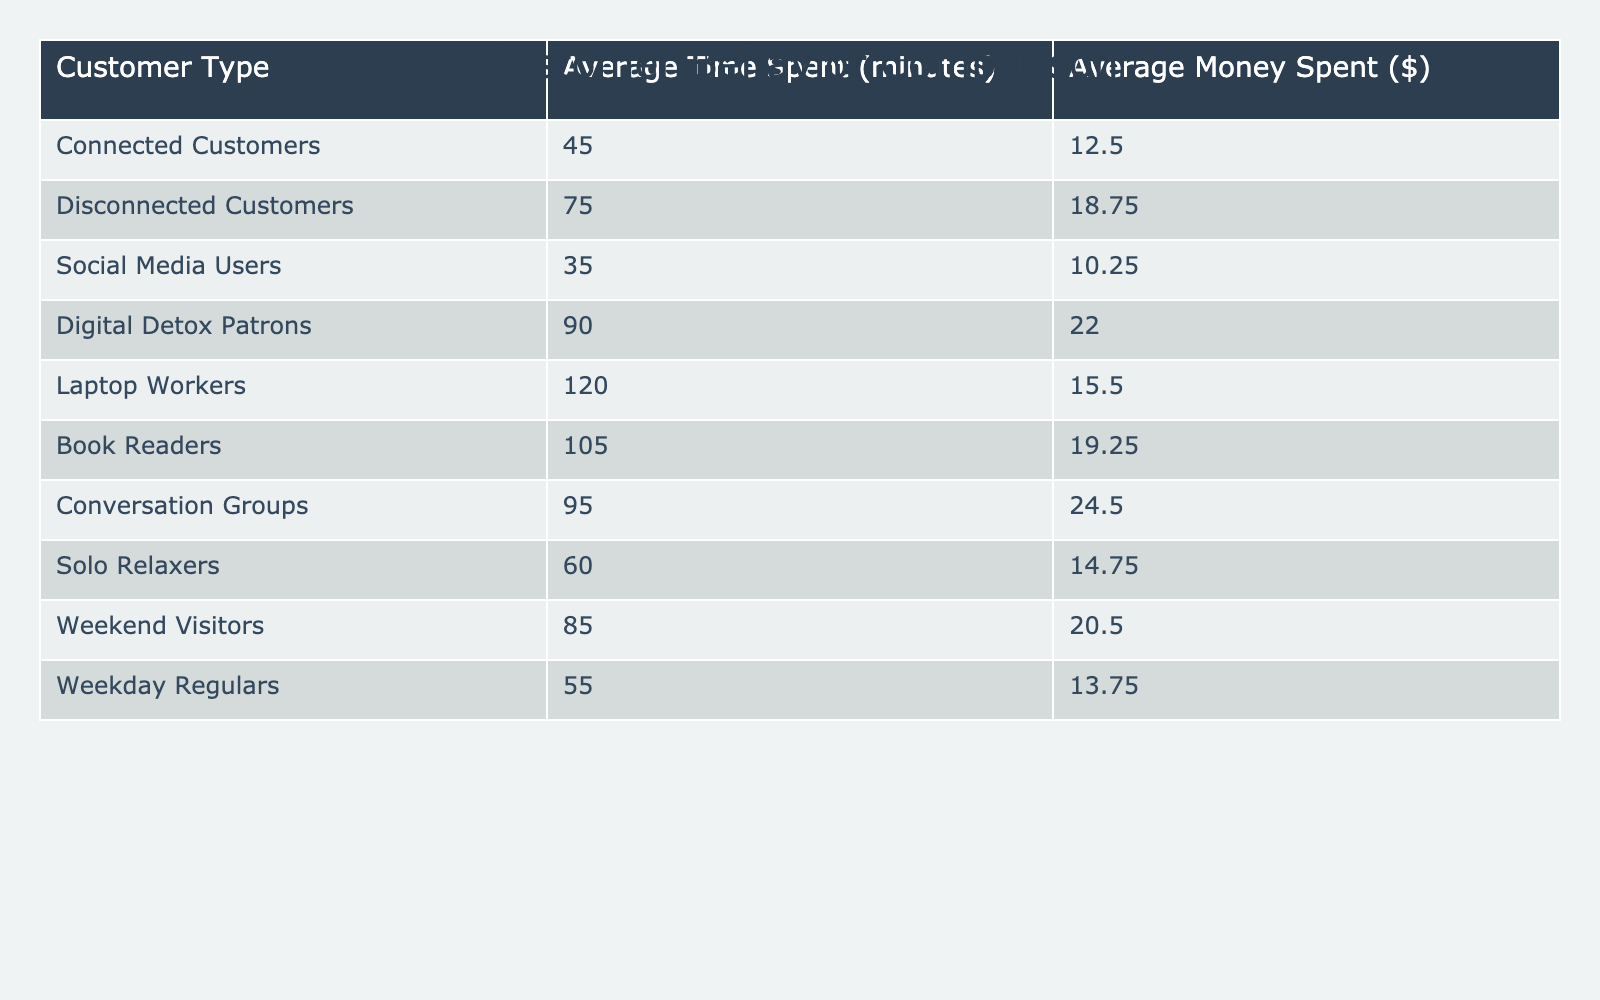What is the average time spent by disconnected customers? According to the table, the average time spent by disconnected customers is explicitly listed as 75 minutes.
Answer: 75 minutes What is the average money spent by connected customers? The table shows the average money spent by connected customers to be $12.50.
Answer: $12.50 Which group spends more on average, connected or disconnected customers? Upon comparing the average money spent by connected customers ($12.50) with disconnected customers ($18.75), disconnected customers spend more.
Answer: Disconnected customers What is the difference in average time spent between connected customers and digital detox patrons? The average time spent by connected customers is 45 minutes, while digital detox patrons spend 90 minutes. The difference is 90 - 45 = 45 minutes.
Answer: 45 minutes How much more money do disconnected customers spend compared to connected customers? Disconnected customers spend an average of $18.75, while connected customers spend $12.50. The difference is $18.75 - $12.50 = $6.25.
Answer: $6.25 What is the total average time spent by connected and disconnected customers combined? The total average time for both categories is 45 minutes (connected) + 75 minutes (disconnected) = 120 minutes.
Answer: 120 minutes True or False: Social media users spend more time on average than weekend visitors. The average time spent by social media users is 35 minutes and weekend visitors spend 85 minutes, so the statement is false.
Answer: False What is the average time spent by all customers in the table? To find the average, sum all average times: 45 + 75 + 35 + 90 + 120 + 105 + 95 + 60 + 85 + 55 = 765 minutes, then divide by the number of groups (10): 765 / 10 = 76.5 minutes.
Answer: 76.5 minutes Which customer type has the highest average money spent, and what is that amount? Looking through the average money spent values, conversation groups have the highest at $24.50.
Answer: Conversation groups, $24.50 What percentage more time do book readers spend compared to connected customers? Book readers spend an average of 105 minutes, while connected customers spend 45 minutes. The percentage increase is ((105 - 45) / 45) * 100 = 133.33%.
Answer: 133.33% 